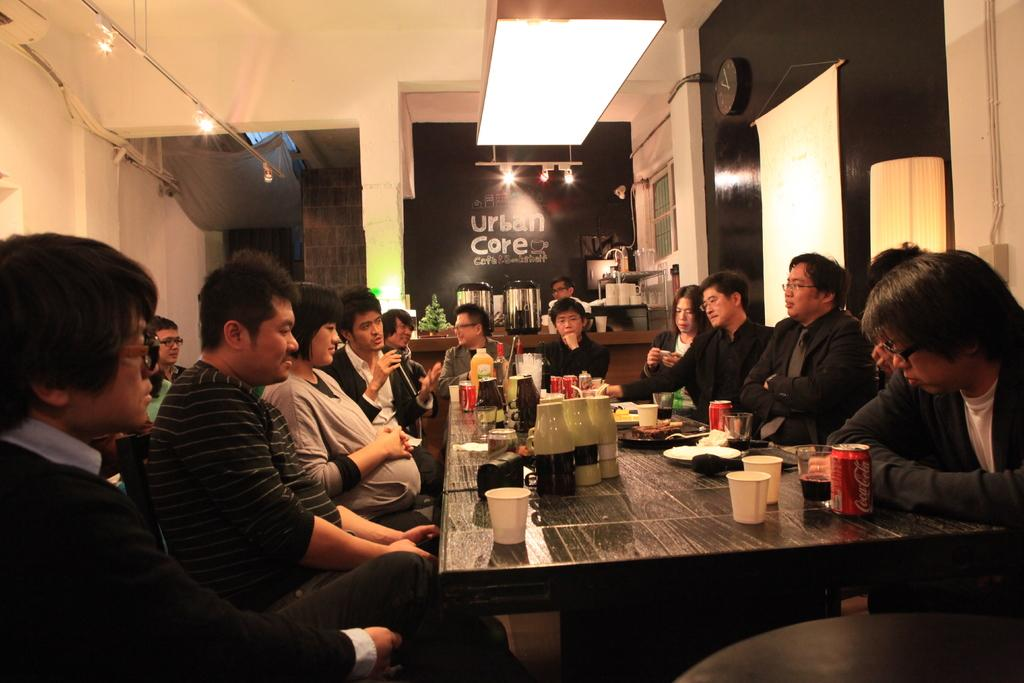Provide a one-sentence caption for the provided image. Many people eating at the Urban Care restaurant. 